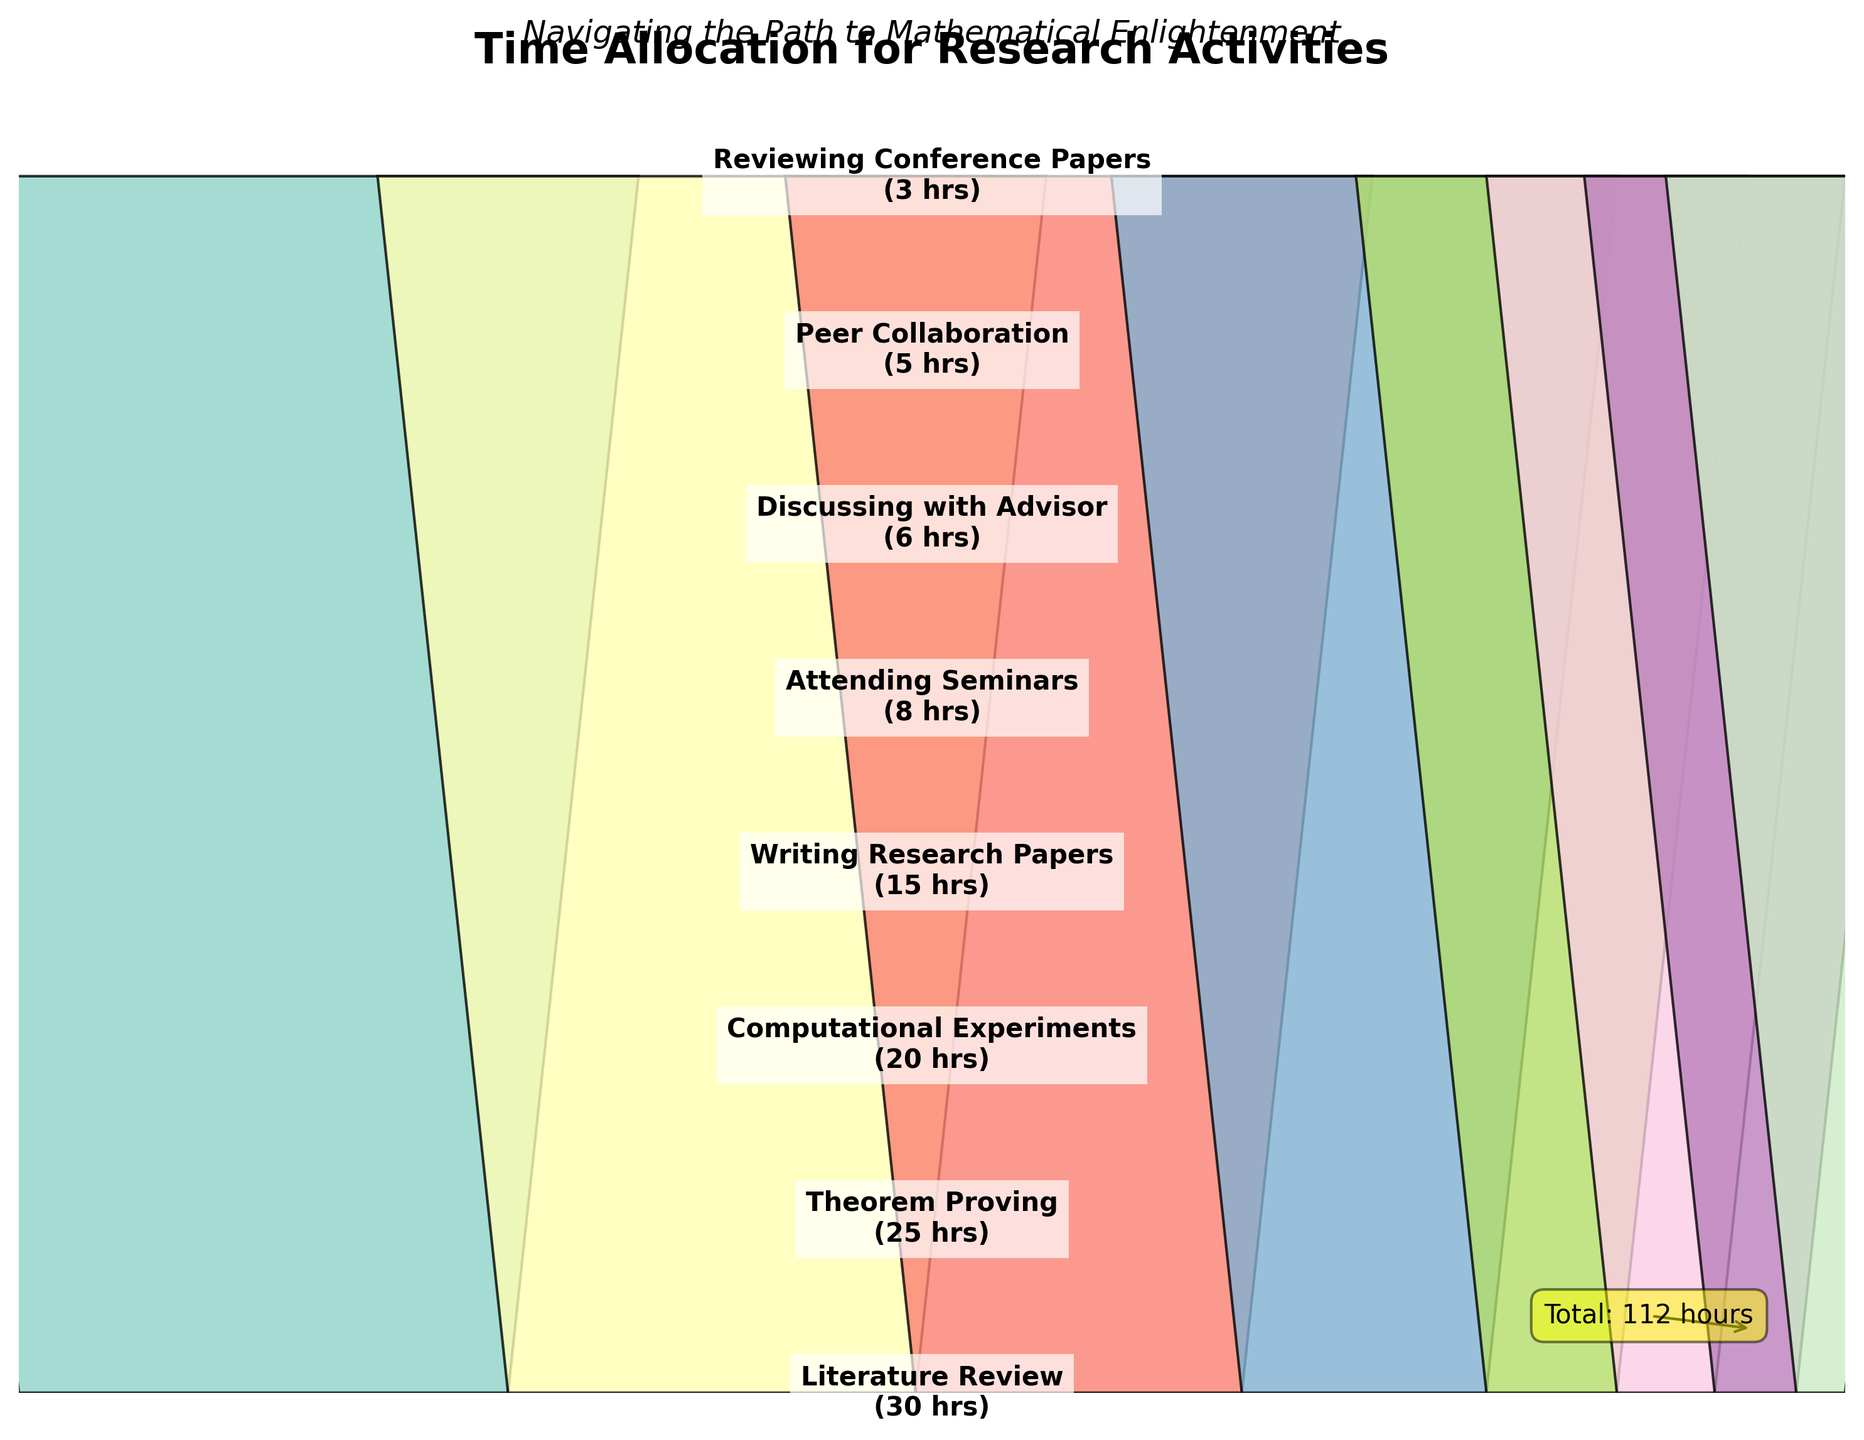What's the title of the funnel chart? The title of the chart can be found at the top and is explicitly stated.
Answer: Time Allocation for Research Activities How many hours are allocated to Theorem Proving? By locating Theorem Proving on the funnel chart and reading the label associated with it, the number of hours can be identified.
Answer: 25 What activity takes up the least amount of time? By examining the smallest section of the funnel chart at the narrow end, one can see the activity with the fewest hours allocated.
Answer: Reviewing Conference Papers Compare the time spent on Literature Review and Writing Research Papers. Which one has more hours? By identifying and comparing the sections labeled Literature Review and Writing Research Papers, the one with a larger width indicates more hours.
Answer: Literature Review Calculate the total hours spent on Theorem Proving and Computational Experiments combined. Locate the hours for Theorem Proving (25) and Computational Experiments (20), then sum these values.
Answer: 45 hours What percentage of the total time is spent on Attending Seminars? Find the total hours (107). Locate the hours for Attending Seminars (8) and compute (8/107)*100 to find the percentage.
Answer: 7.48% Compare the total time spent discussing with an advisor and peer collaboration. Which is greater and by how many hours? Locate the hours for Discussing with Advisor (6) and Peer Collaboration (5). Subtract the smaller from the larger to find the difference.
Answer: Discussing with Advisor by 1 hour If you wanted to reduce the time spent on Literature Review and redistribute it to Writing Research Papers equally, how many additional hours would each activity have? Subtract a desired reduction amount from Literature Review and divide that number by 2 to distribute it equally. Example: reducing Literature Review by 10 hours to 20 and adding 5 hours each to Writing Research Papers (20).
Answer: Literature Review: 20 hours, Writing Research Papers: 20 hours Which activities combined account for exactly half of the total weekly hours? List activities and their hours, sum sequentially until reaching or exceeding half of 107 hours (53.5 hours). Identify activities up to or around this cumulative total.
Answer: Literature Review, Theorem Proving, Computational Experiments What is the difference between the most time-consuming activity and the least time-consuming activity? Find the hours for the most time-consuming (Literature Review, 30) and least time-consuming (Reviewing Conference Papers, 3). Subtract the smaller from the larger.
Answer: 27 hours 